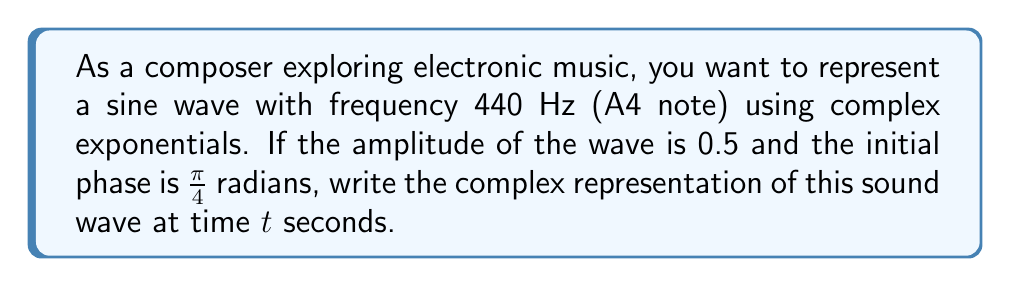Give your solution to this math problem. Let's approach this step-by-step:

1) The general form of a complex representation of a sine wave is:

   $$f(t) = Ae^{i(\omega t + \phi)}$$

   where $A$ is the amplitude, $\omega$ is the angular frequency, and $\phi$ is the initial phase.

2) We're given:
   - Amplitude $A = 0.5$
   - Frequency $f = 440$ Hz
   - Initial phase $\phi = \frac{\pi}{4}$ radians

3) We need to calculate the angular frequency $\omega$:
   $$\omega = 2\pi f = 2\pi(440) = 880\pi \text{ rad/s}$$

4) Now we can substitute these values into our general form:

   $$f(t) = 0.5e^{i(880\pi t + \frac{\pi}{4})}$$

5) This expression represents the complex-valued function of the sound wave at any time $t$.

6) In electronic music composition, this representation allows for easy manipulation of the wave's properties and facilitates operations like frequency modulation or additive synthesis.
Answer: $f(t) = 0.5e^{i(880\pi t + \frac{\pi}{4})}$ 